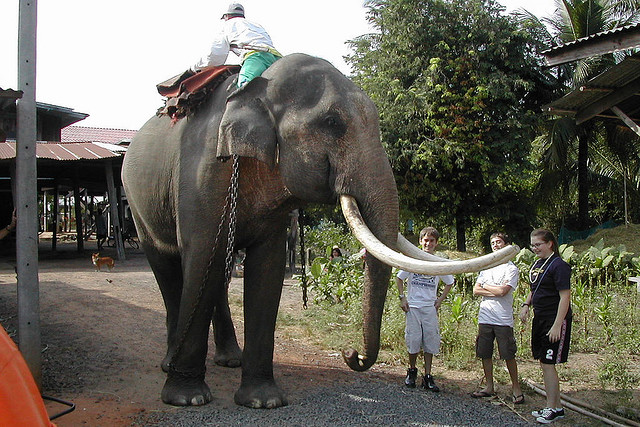Please extract the text content from this image. 2 